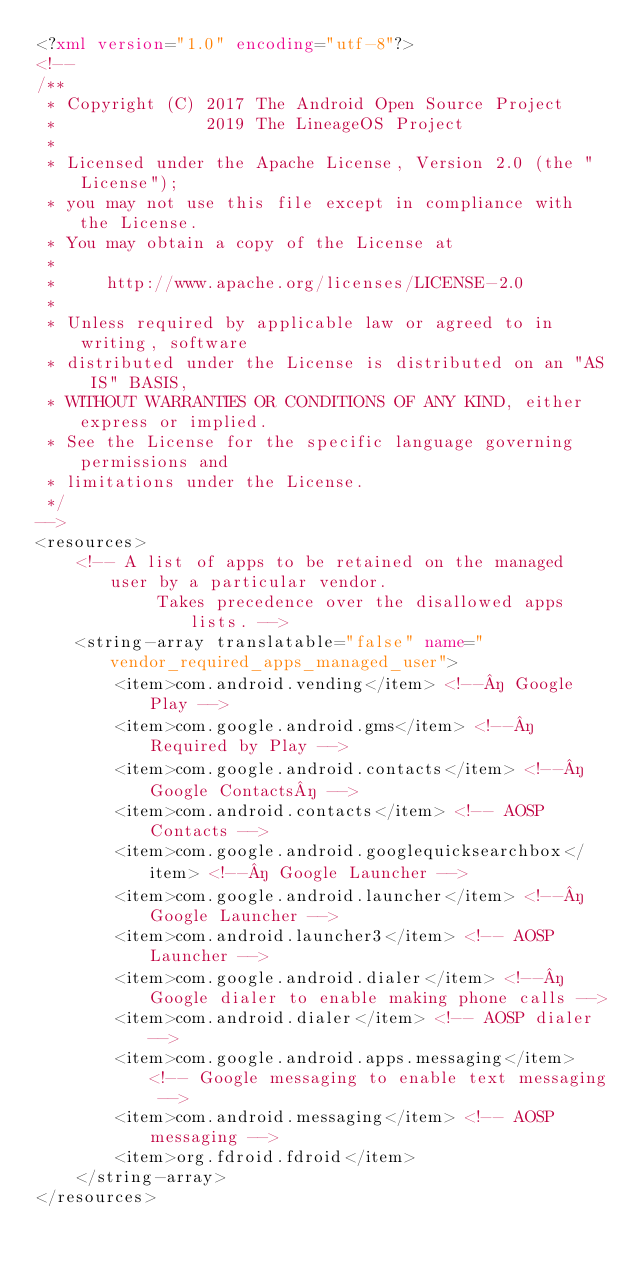Convert code to text. <code><loc_0><loc_0><loc_500><loc_500><_XML_><?xml version="1.0" encoding="utf-8"?>
<!--
/**
 * Copyright (C) 2017 The Android Open Source Project
 *               2019 The LineageOS Project
 *
 * Licensed under the Apache License, Version 2.0 (the "License");
 * you may not use this file except in compliance with the License.
 * You may obtain a copy of the License at
 *
 *     http://www.apache.org/licenses/LICENSE-2.0
 *
 * Unless required by applicable law or agreed to in writing, software
 * distributed under the License is distributed on an "AS IS" BASIS,
 * WITHOUT WARRANTIES OR CONDITIONS OF ANY KIND, either express or implied.
 * See the License for the specific language governing permissions and
 * limitations under the License.
 */
-->
<resources>
    <!-- A list of apps to be retained on the managed user by a particular vendor.
            Takes precedence over the disallowed apps lists. -->
    <string-array translatable="false" name="vendor_required_apps_managed_user">
        <item>com.android.vending</item> <!--­ Google Play -->
        <item>com.google.android.gms</item> <!--­ Required by Play -->
        <item>com.google.android.contacts</item> <!--­ Google Contacts­ -->
        <item>com.android.contacts</item> <!-- AOSP Contacts -->
        <item>com.google.android.googlequicksearchbox</item> <!--­ Google Launcher -->
        <item>com.google.android.launcher</item> <!--­ Google Launcher -->
        <item>com.android.launcher3</item> <!-- AOSP Launcher -->
        <item>com.google.android.dialer</item> <!--­ Google dialer to enable making phone calls -->
        <item>com.android.dialer</item> <!-- AOSP dialer -->
        <item>com.google.android.apps.messaging</item> <!-- Google messaging to enable text messaging -->
        <item>com.android.messaging</item> <!-- AOSP messaging -->
        <item>org.fdroid.fdroid</item>
    </string-array>
</resources>
</code> 